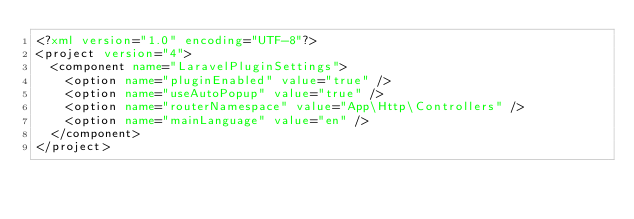<code> <loc_0><loc_0><loc_500><loc_500><_XML_><?xml version="1.0" encoding="UTF-8"?>
<project version="4">
  <component name="LaravelPluginSettings">
    <option name="pluginEnabled" value="true" />
    <option name="useAutoPopup" value="true" />
    <option name="routerNamespace" value="App\Http\Controllers" />
    <option name="mainLanguage" value="en" />
  </component>
</project></code> 